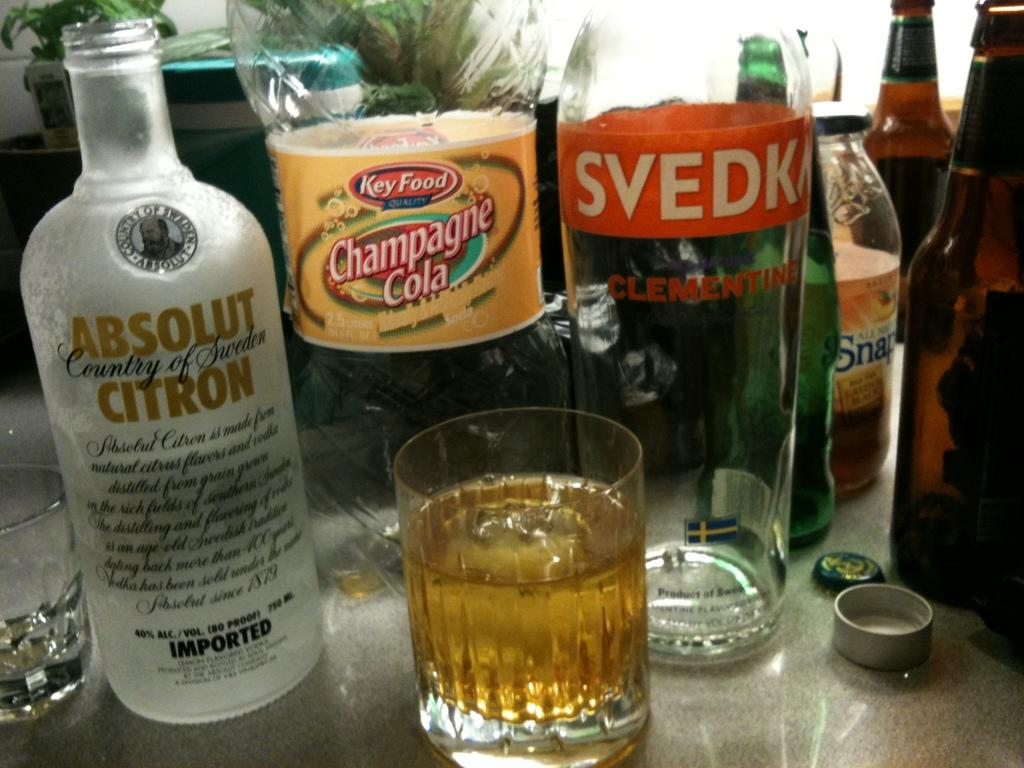<image>
Summarize the visual content of the image. Multiple bottles of alcohol and a cola bottle are lined up in front of glass. 